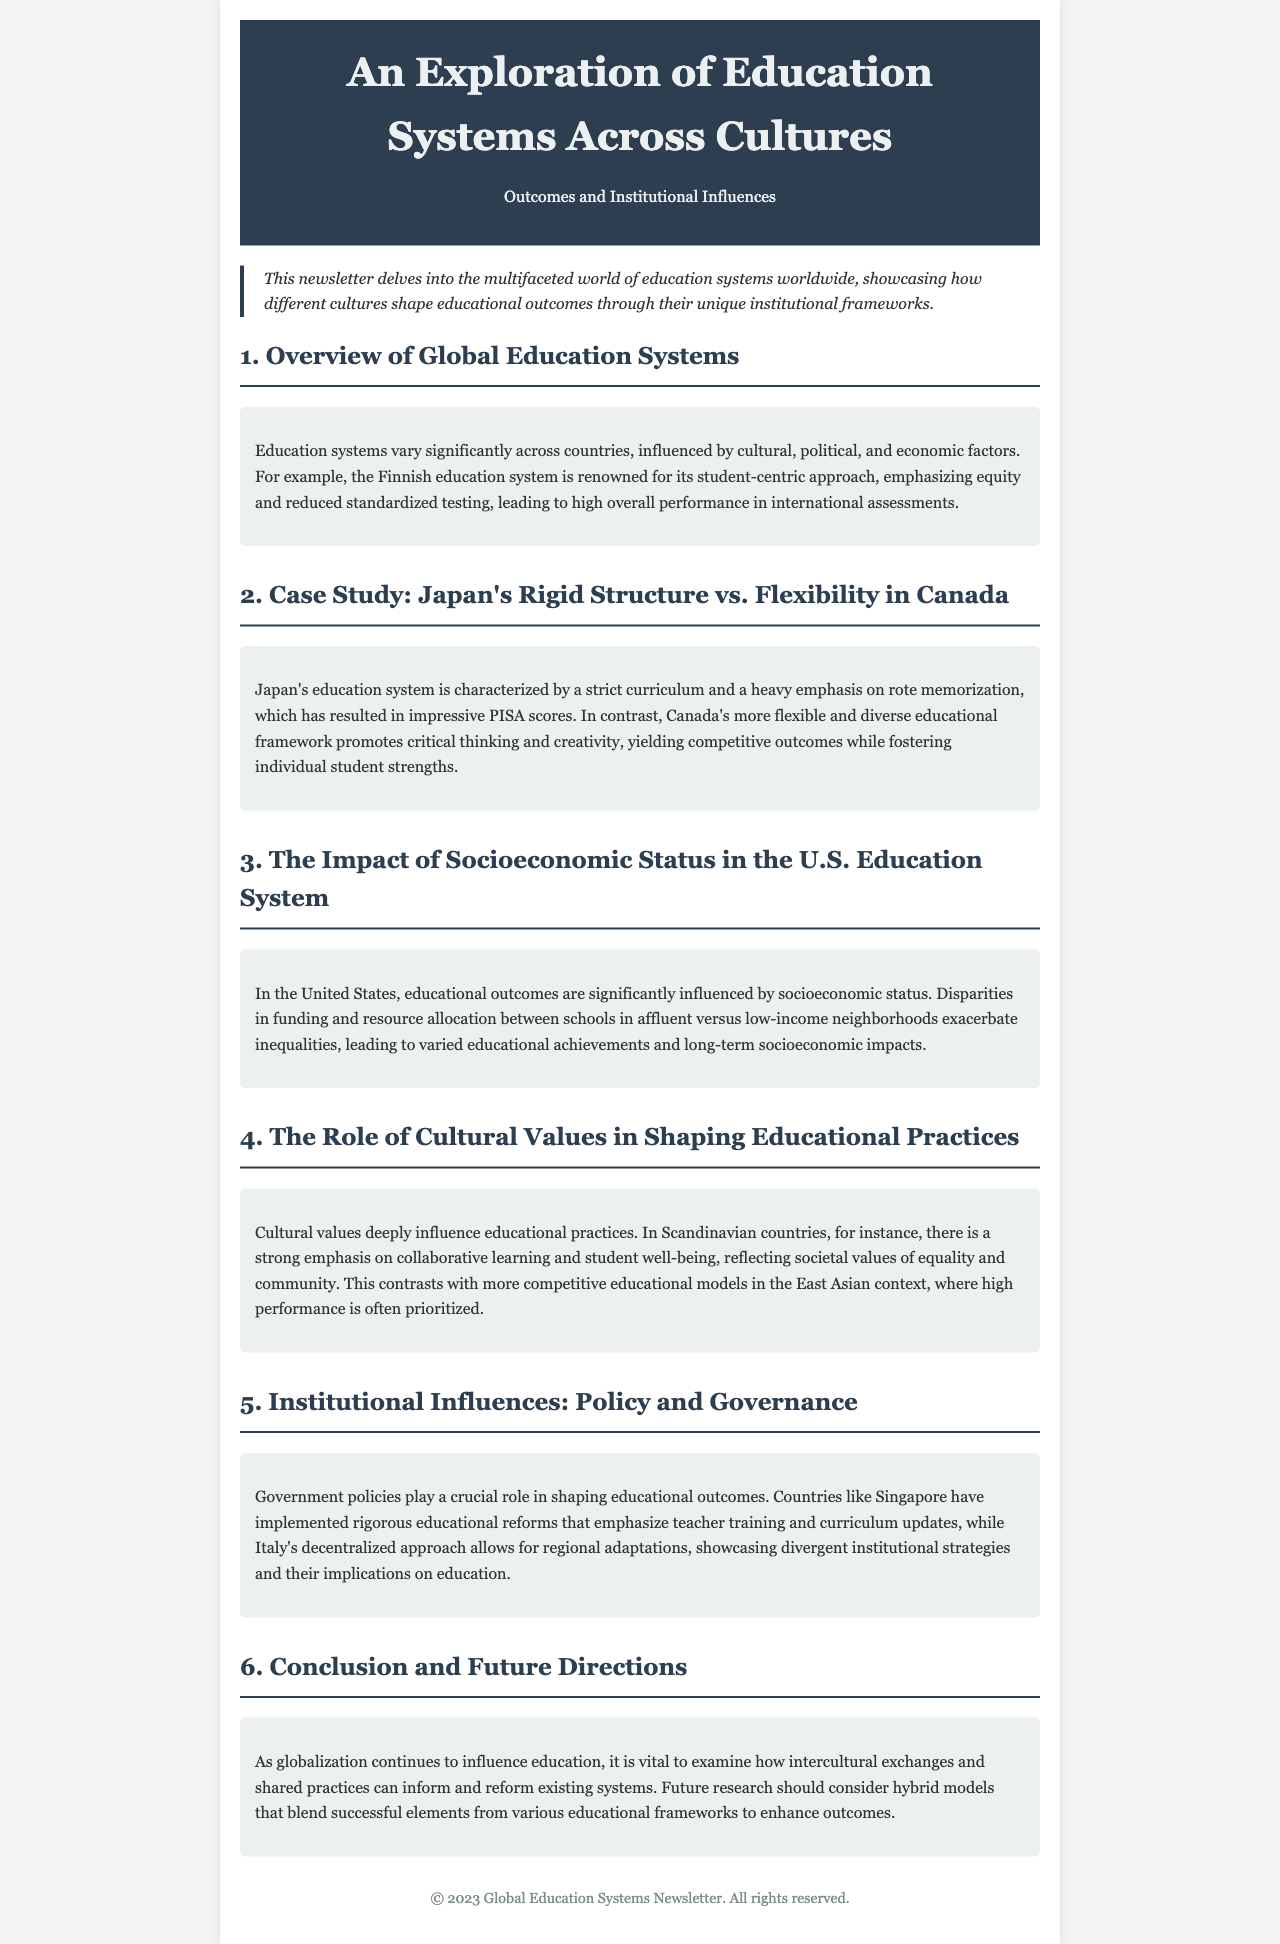What is the title of the newsletter? The title of the newsletter is found in the header section of the document.
Answer: An Exploration of Education Systems Across Cultures Which country is noted for its student-centric approach in education? The country is mentioned in the overview section as having a renowned education system.
Answer: Finland What are the two contrasting educational systems discussed in the case study? The case study compares two specific countries' education systems as highlighted in the section.
Answer: Japan and Canada What socioeconomic factor influences the U.S. education system? The specific factor is mentioned in relation to funding and resource allocation disparities.
Answer: Socioeconomic status What is emphasized in Scandinavian countries regarding educational practices? This information is provided in a section discussing cultural values and its influence on education.
Answer: Collaborative learning Which country has implemented rigorous educational reforms focusing on teacher training? The country is referenced in the section discussing policy and governance in education systems.
Answer: Singapore What contrasting approach is taken by Italy regarding education policy? The approach is discussed in relation to how it impacts regional educational adaptations.
Answer: Decentralized approach What should future research consider to enhance educational outcomes? This point is concluded in the document's final section regarding future directions in education.
Answer: Hybrid models 